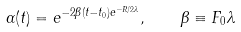<formula> <loc_0><loc_0><loc_500><loc_500>\alpha ( t ) = e ^ { - 2 \beta ( t - t _ { 0 } ) e ^ { - R / 2 \lambda } } , \quad \beta \equiv F _ { 0 } \lambda</formula> 